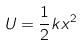<formula> <loc_0><loc_0><loc_500><loc_500>U = \frac { 1 } { 2 } k x ^ { 2 }</formula> 